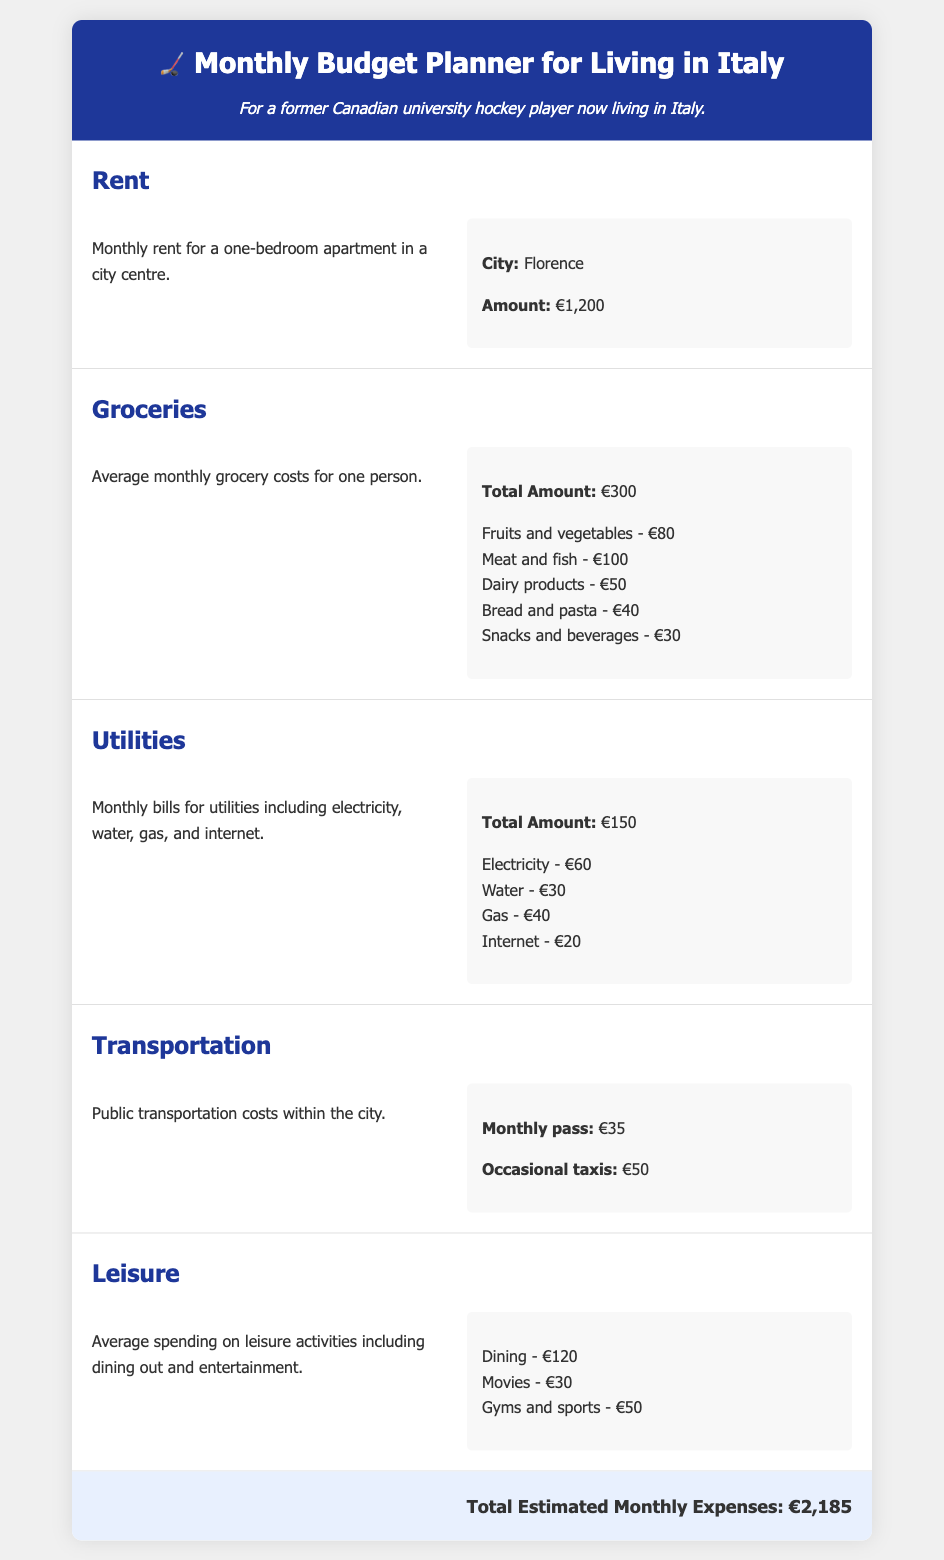What is the monthly rent for a one-bedroom apartment? The document specifies the monthly rent for a one-bedroom apartment in Florence as €1,200.
Answer: €1,200 What are the grocery costs for fruits and vegetables? The grocery costs for fruits and vegetables are detailed as part of the overall grocery expenses, amounting to €80.
Answer: €80 What is the total amount for utilities? The total amount for utilities, which includes bills for electricity, water, gas, and internet, is stated as €150.
Answer: €150 How much does a monthly transportation pass cost? The document mentions that a monthly transportation pass costs €35.
Answer: €35 What is the total estimated monthly expense? The total estimated monthly expenses, which sum up all individual costs, is indicated as €2,185.
Answer: €2,185 How much is allocated for dining in the leisure section? The leisure section allocates €120 specifically for dining out.
Answer: €120 What is the average spending on gyms and sports? The document states that the average spending on gyms and sports is €50.
Answer: €50 What expenses are included in the utilities category? The utilities category includes electricity, water, gas, and internet for a total of €150.
Answer: Electricity, water, gas, internet What city is the rent example from? The rent example is specified for the city of Florence.
Answer: Florence 